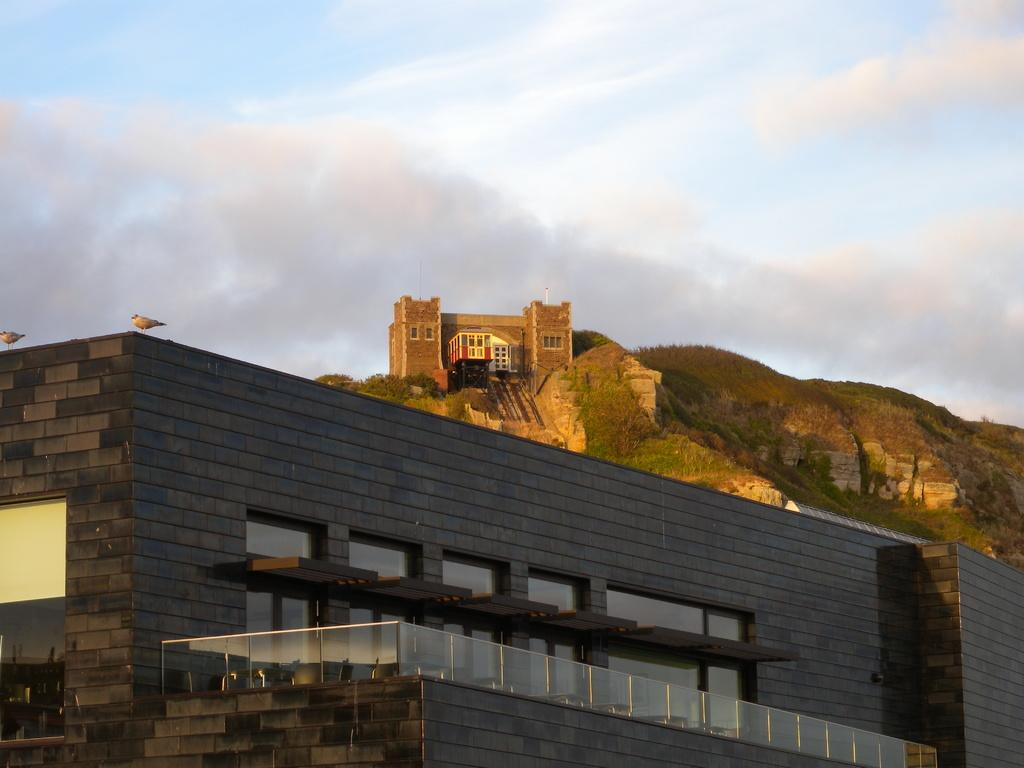What type of structure is present with plants in the image? There is a building with plants in the image. What type of furniture can be seen in the image? There are chairs in the image. What type of animals are present in the image? There are birds in the image. What type of landscape feature is present in the image? There is another building on top of a hill in the image. What is visible in the background of the image? The sky is visible in the background of the image. What type of needle is being used to sew the umbrella in the image? There is no umbrella or needle present in the image. What emotion is being expressed by the disgusting creature in the image? There is no creature, disgusting or otherwise, present in the image. 